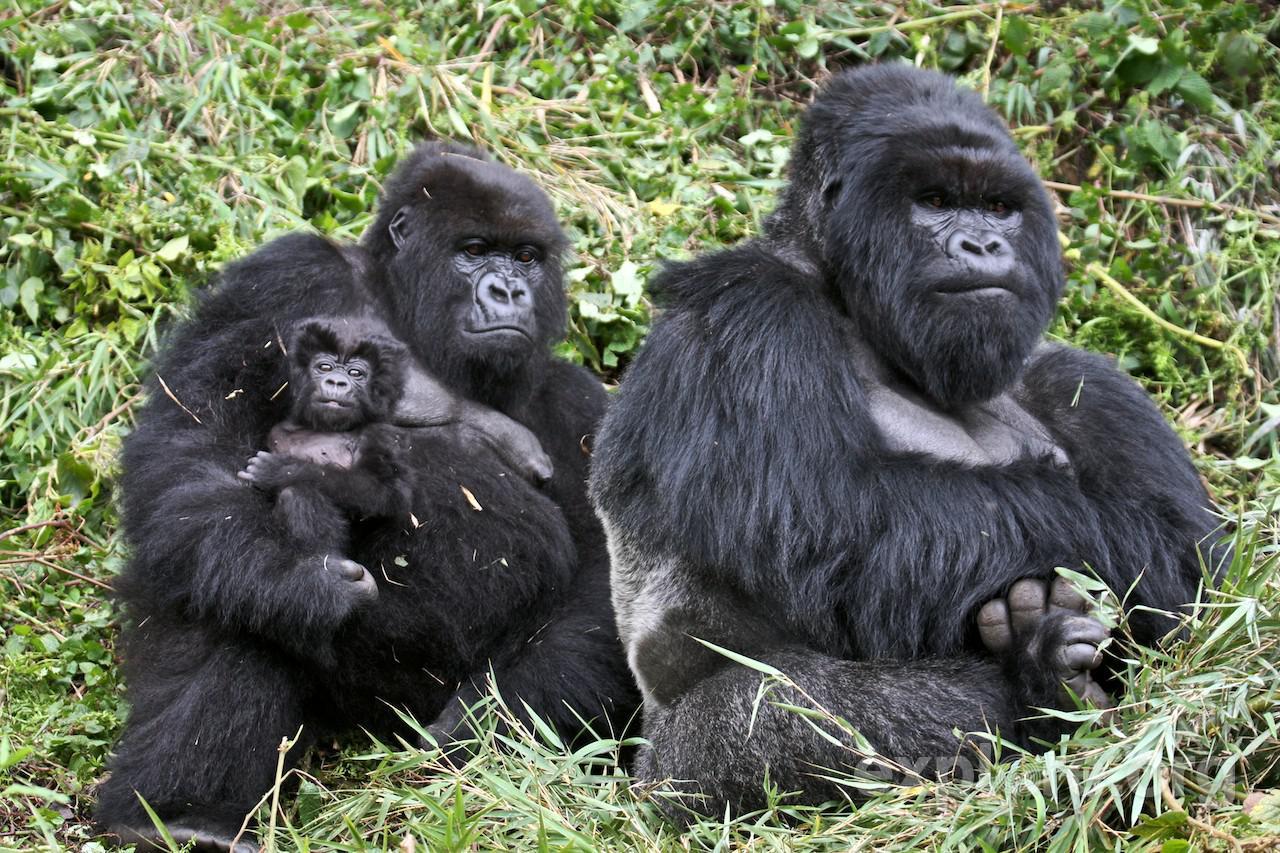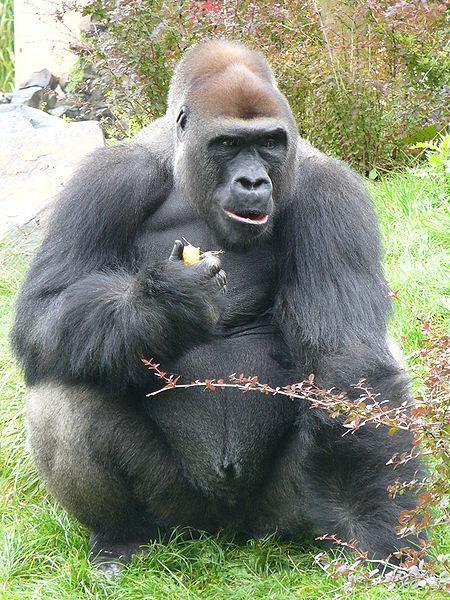The first image is the image on the left, the second image is the image on the right. Evaluate the accuracy of this statement regarding the images: "There is one sitting gorilla in the image on the right.". Is it true? Answer yes or no. Yes. 